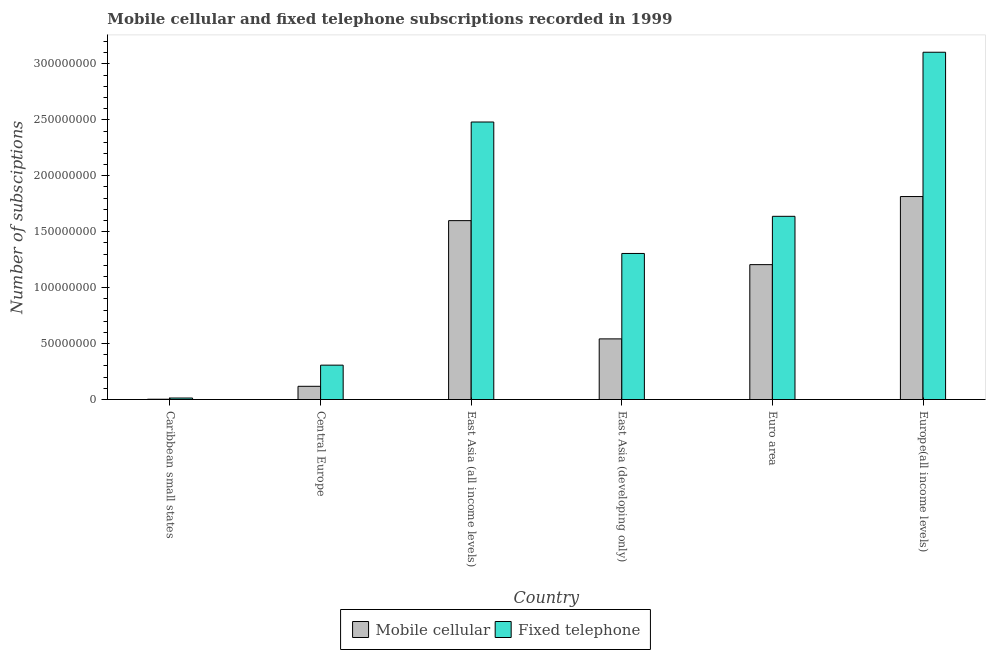How many groups of bars are there?
Your response must be concise. 6. Are the number of bars on each tick of the X-axis equal?
Offer a very short reply. Yes. How many bars are there on the 4th tick from the left?
Offer a terse response. 2. What is the label of the 6th group of bars from the left?
Provide a short and direct response. Europe(all income levels). In how many cases, is the number of bars for a given country not equal to the number of legend labels?
Keep it short and to the point. 0. What is the number of fixed telephone subscriptions in Europe(all income levels)?
Keep it short and to the point. 3.10e+08. Across all countries, what is the maximum number of fixed telephone subscriptions?
Your answer should be compact. 3.10e+08. Across all countries, what is the minimum number of fixed telephone subscriptions?
Give a very brief answer. 1.34e+06. In which country was the number of mobile cellular subscriptions maximum?
Your answer should be compact. Europe(all income levels). In which country was the number of mobile cellular subscriptions minimum?
Your answer should be compact. Caribbean small states. What is the total number of fixed telephone subscriptions in the graph?
Your answer should be very brief. 8.85e+08. What is the difference between the number of mobile cellular subscriptions in East Asia (developing only) and that in Euro area?
Offer a terse response. -6.64e+07. What is the difference between the number of fixed telephone subscriptions in East Asia (developing only) and the number of mobile cellular subscriptions in Central Europe?
Give a very brief answer. 1.19e+08. What is the average number of fixed telephone subscriptions per country?
Make the answer very short. 1.47e+08. What is the difference between the number of fixed telephone subscriptions and number of mobile cellular subscriptions in Central Europe?
Give a very brief answer. 1.89e+07. What is the ratio of the number of fixed telephone subscriptions in East Asia (developing only) to that in Euro area?
Make the answer very short. 0.8. Is the number of mobile cellular subscriptions in Caribbean small states less than that in Europe(all income levels)?
Provide a short and direct response. Yes. Is the difference between the number of mobile cellular subscriptions in Central Europe and Euro area greater than the difference between the number of fixed telephone subscriptions in Central Europe and Euro area?
Offer a terse response. Yes. What is the difference between the highest and the second highest number of mobile cellular subscriptions?
Ensure brevity in your answer.  2.15e+07. What is the difference between the highest and the lowest number of fixed telephone subscriptions?
Offer a very short reply. 3.09e+08. Is the sum of the number of mobile cellular subscriptions in Caribbean small states and East Asia (developing only) greater than the maximum number of fixed telephone subscriptions across all countries?
Ensure brevity in your answer.  No. What does the 2nd bar from the left in East Asia (all income levels) represents?
Give a very brief answer. Fixed telephone. What does the 2nd bar from the right in Europe(all income levels) represents?
Make the answer very short. Mobile cellular. How many bars are there?
Provide a short and direct response. 12. What is the difference between two consecutive major ticks on the Y-axis?
Give a very brief answer. 5.00e+07. Does the graph contain any zero values?
Your answer should be very brief. No. What is the title of the graph?
Offer a terse response. Mobile cellular and fixed telephone subscriptions recorded in 1999. Does "Register a business" appear as one of the legend labels in the graph?
Offer a very short reply. No. What is the label or title of the X-axis?
Your answer should be compact. Country. What is the label or title of the Y-axis?
Keep it short and to the point. Number of subsciptions. What is the Number of subsciptions of Mobile cellular in Caribbean small states?
Ensure brevity in your answer.  2.62e+05. What is the Number of subsciptions in Fixed telephone in Caribbean small states?
Ensure brevity in your answer.  1.34e+06. What is the Number of subsciptions in Mobile cellular in Central Europe?
Your response must be concise. 1.18e+07. What is the Number of subsciptions of Fixed telephone in Central Europe?
Your answer should be very brief. 3.07e+07. What is the Number of subsciptions of Mobile cellular in East Asia (all income levels)?
Your answer should be compact. 1.60e+08. What is the Number of subsciptions in Fixed telephone in East Asia (all income levels)?
Your answer should be very brief. 2.48e+08. What is the Number of subsciptions in Mobile cellular in East Asia (developing only)?
Your response must be concise. 5.42e+07. What is the Number of subsciptions of Fixed telephone in East Asia (developing only)?
Give a very brief answer. 1.31e+08. What is the Number of subsciptions of Mobile cellular in Euro area?
Ensure brevity in your answer.  1.21e+08. What is the Number of subsciptions in Fixed telephone in Euro area?
Offer a very short reply. 1.64e+08. What is the Number of subsciptions in Mobile cellular in Europe(all income levels)?
Make the answer very short. 1.81e+08. What is the Number of subsciptions of Fixed telephone in Europe(all income levels)?
Your answer should be very brief. 3.10e+08. Across all countries, what is the maximum Number of subsciptions in Mobile cellular?
Your answer should be very brief. 1.81e+08. Across all countries, what is the maximum Number of subsciptions in Fixed telephone?
Provide a short and direct response. 3.10e+08. Across all countries, what is the minimum Number of subsciptions of Mobile cellular?
Your response must be concise. 2.62e+05. Across all countries, what is the minimum Number of subsciptions of Fixed telephone?
Ensure brevity in your answer.  1.34e+06. What is the total Number of subsciptions in Mobile cellular in the graph?
Your answer should be compact. 5.28e+08. What is the total Number of subsciptions in Fixed telephone in the graph?
Your answer should be compact. 8.85e+08. What is the difference between the Number of subsciptions of Mobile cellular in Caribbean small states and that in Central Europe?
Your response must be concise. -1.16e+07. What is the difference between the Number of subsciptions of Fixed telephone in Caribbean small states and that in Central Europe?
Offer a terse response. -2.94e+07. What is the difference between the Number of subsciptions in Mobile cellular in Caribbean small states and that in East Asia (all income levels)?
Make the answer very short. -1.60e+08. What is the difference between the Number of subsciptions of Fixed telephone in Caribbean small states and that in East Asia (all income levels)?
Ensure brevity in your answer.  -2.47e+08. What is the difference between the Number of subsciptions in Mobile cellular in Caribbean small states and that in East Asia (developing only)?
Offer a very short reply. -5.39e+07. What is the difference between the Number of subsciptions of Fixed telephone in Caribbean small states and that in East Asia (developing only)?
Your response must be concise. -1.29e+08. What is the difference between the Number of subsciptions in Mobile cellular in Caribbean small states and that in Euro area?
Your answer should be compact. -1.20e+08. What is the difference between the Number of subsciptions of Fixed telephone in Caribbean small states and that in Euro area?
Make the answer very short. -1.62e+08. What is the difference between the Number of subsciptions in Mobile cellular in Caribbean small states and that in Europe(all income levels)?
Offer a terse response. -1.81e+08. What is the difference between the Number of subsciptions in Fixed telephone in Caribbean small states and that in Europe(all income levels)?
Provide a short and direct response. -3.09e+08. What is the difference between the Number of subsciptions in Mobile cellular in Central Europe and that in East Asia (all income levels)?
Your answer should be very brief. -1.48e+08. What is the difference between the Number of subsciptions of Fixed telephone in Central Europe and that in East Asia (all income levels)?
Provide a succinct answer. -2.17e+08. What is the difference between the Number of subsciptions in Mobile cellular in Central Europe and that in East Asia (developing only)?
Make the answer very short. -4.24e+07. What is the difference between the Number of subsciptions in Fixed telephone in Central Europe and that in East Asia (developing only)?
Keep it short and to the point. -9.98e+07. What is the difference between the Number of subsciptions in Mobile cellular in Central Europe and that in Euro area?
Keep it short and to the point. -1.09e+08. What is the difference between the Number of subsciptions of Fixed telephone in Central Europe and that in Euro area?
Give a very brief answer. -1.33e+08. What is the difference between the Number of subsciptions in Mobile cellular in Central Europe and that in Europe(all income levels)?
Offer a terse response. -1.70e+08. What is the difference between the Number of subsciptions of Fixed telephone in Central Europe and that in Europe(all income levels)?
Provide a short and direct response. -2.80e+08. What is the difference between the Number of subsciptions in Mobile cellular in East Asia (all income levels) and that in East Asia (developing only)?
Keep it short and to the point. 1.06e+08. What is the difference between the Number of subsciptions of Fixed telephone in East Asia (all income levels) and that in East Asia (developing only)?
Ensure brevity in your answer.  1.18e+08. What is the difference between the Number of subsciptions in Mobile cellular in East Asia (all income levels) and that in Euro area?
Provide a short and direct response. 3.93e+07. What is the difference between the Number of subsciptions of Fixed telephone in East Asia (all income levels) and that in Euro area?
Provide a short and direct response. 8.43e+07. What is the difference between the Number of subsciptions in Mobile cellular in East Asia (all income levels) and that in Europe(all income levels)?
Your response must be concise. -2.15e+07. What is the difference between the Number of subsciptions in Fixed telephone in East Asia (all income levels) and that in Europe(all income levels)?
Provide a succinct answer. -6.24e+07. What is the difference between the Number of subsciptions in Mobile cellular in East Asia (developing only) and that in Euro area?
Ensure brevity in your answer.  -6.64e+07. What is the difference between the Number of subsciptions of Fixed telephone in East Asia (developing only) and that in Euro area?
Provide a short and direct response. -3.32e+07. What is the difference between the Number of subsciptions of Mobile cellular in East Asia (developing only) and that in Europe(all income levels)?
Give a very brief answer. -1.27e+08. What is the difference between the Number of subsciptions of Fixed telephone in East Asia (developing only) and that in Europe(all income levels)?
Offer a very short reply. -1.80e+08. What is the difference between the Number of subsciptions of Mobile cellular in Euro area and that in Europe(all income levels)?
Keep it short and to the point. -6.09e+07. What is the difference between the Number of subsciptions in Fixed telephone in Euro area and that in Europe(all income levels)?
Provide a short and direct response. -1.47e+08. What is the difference between the Number of subsciptions in Mobile cellular in Caribbean small states and the Number of subsciptions in Fixed telephone in Central Europe?
Give a very brief answer. -3.05e+07. What is the difference between the Number of subsciptions of Mobile cellular in Caribbean small states and the Number of subsciptions of Fixed telephone in East Asia (all income levels)?
Ensure brevity in your answer.  -2.48e+08. What is the difference between the Number of subsciptions in Mobile cellular in Caribbean small states and the Number of subsciptions in Fixed telephone in East Asia (developing only)?
Your response must be concise. -1.30e+08. What is the difference between the Number of subsciptions of Mobile cellular in Caribbean small states and the Number of subsciptions of Fixed telephone in Euro area?
Your response must be concise. -1.63e+08. What is the difference between the Number of subsciptions in Mobile cellular in Caribbean small states and the Number of subsciptions in Fixed telephone in Europe(all income levels)?
Your response must be concise. -3.10e+08. What is the difference between the Number of subsciptions in Mobile cellular in Central Europe and the Number of subsciptions in Fixed telephone in East Asia (all income levels)?
Make the answer very short. -2.36e+08. What is the difference between the Number of subsciptions in Mobile cellular in Central Europe and the Number of subsciptions in Fixed telephone in East Asia (developing only)?
Offer a terse response. -1.19e+08. What is the difference between the Number of subsciptions of Mobile cellular in Central Europe and the Number of subsciptions of Fixed telephone in Euro area?
Ensure brevity in your answer.  -1.52e+08. What is the difference between the Number of subsciptions of Mobile cellular in Central Europe and the Number of subsciptions of Fixed telephone in Europe(all income levels)?
Your response must be concise. -2.99e+08. What is the difference between the Number of subsciptions of Mobile cellular in East Asia (all income levels) and the Number of subsciptions of Fixed telephone in East Asia (developing only)?
Your response must be concise. 2.94e+07. What is the difference between the Number of subsciptions in Mobile cellular in East Asia (all income levels) and the Number of subsciptions in Fixed telephone in Euro area?
Your answer should be compact. -3.85e+06. What is the difference between the Number of subsciptions of Mobile cellular in East Asia (all income levels) and the Number of subsciptions of Fixed telephone in Europe(all income levels)?
Your answer should be very brief. -1.51e+08. What is the difference between the Number of subsciptions of Mobile cellular in East Asia (developing only) and the Number of subsciptions of Fixed telephone in Euro area?
Provide a succinct answer. -1.10e+08. What is the difference between the Number of subsciptions of Mobile cellular in East Asia (developing only) and the Number of subsciptions of Fixed telephone in Europe(all income levels)?
Your answer should be compact. -2.56e+08. What is the difference between the Number of subsciptions in Mobile cellular in Euro area and the Number of subsciptions in Fixed telephone in Europe(all income levels)?
Your answer should be very brief. -1.90e+08. What is the average Number of subsciptions in Mobile cellular per country?
Provide a short and direct response. 8.80e+07. What is the average Number of subsciptions of Fixed telephone per country?
Ensure brevity in your answer.  1.47e+08. What is the difference between the Number of subsciptions of Mobile cellular and Number of subsciptions of Fixed telephone in Caribbean small states?
Make the answer very short. -1.08e+06. What is the difference between the Number of subsciptions in Mobile cellular and Number of subsciptions in Fixed telephone in Central Europe?
Make the answer very short. -1.89e+07. What is the difference between the Number of subsciptions in Mobile cellular and Number of subsciptions in Fixed telephone in East Asia (all income levels)?
Offer a terse response. -8.82e+07. What is the difference between the Number of subsciptions of Mobile cellular and Number of subsciptions of Fixed telephone in East Asia (developing only)?
Keep it short and to the point. -7.63e+07. What is the difference between the Number of subsciptions of Mobile cellular and Number of subsciptions of Fixed telephone in Euro area?
Ensure brevity in your answer.  -4.32e+07. What is the difference between the Number of subsciptions in Mobile cellular and Number of subsciptions in Fixed telephone in Europe(all income levels)?
Your answer should be compact. -1.29e+08. What is the ratio of the Number of subsciptions of Mobile cellular in Caribbean small states to that in Central Europe?
Give a very brief answer. 0.02. What is the ratio of the Number of subsciptions of Fixed telephone in Caribbean small states to that in Central Europe?
Your answer should be very brief. 0.04. What is the ratio of the Number of subsciptions in Mobile cellular in Caribbean small states to that in East Asia (all income levels)?
Offer a very short reply. 0. What is the ratio of the Number of subsciptions in Fixed telephone in Caribbean small states to that in East Asia (all income levels)?
Your answer should be compact. 0.01. What is the ratio of the Number of subsciptions in Mobile cellular in Caribbean small states to that in East Asia (developing only)?
Offer a very short reply. 0. What is the ratio of the Number of subsciptions of Fixed telephone in Caribbean small states to that in East Asia (developing only)?
Offer a very short reply. 0.01. What is the ratio of the Number of subsciptions in Mobile cellular in Caribbean small states to that in Euro area?
Offer a terse response. 0. What is the ratio of the Number of subsciptions of Fixed telephone in Caribbean small states to that in Euro area?
Offer a terse response. 0.01. What is the ratio of the Number of subsciptions of Mobile cellular in Caribbean small states to that in Europe(all income levels)?
Make the answer very short. 0. What is the ratio of the Number of subsciptions in Fixed telephone in Caribbean small states to that in Europe(all income levels)?
Ensure brevity in your answer.  0. What is the ratio of the Number of subsciptions of Mobile cellular in Central Europe to that in East Asia (all income levels)?
Offer a terse response. 0.07. What is the ratio of the Number of subsciptions in Fixed telephone in Central Europe to that in East Asia (all income levels)?
Ensure brevity in your answer.  0.12. What is the ratio of the Number of subsciptions in Mobile cellular in Central Europe to that in East Asia (developing only)?
Provide a short and direct response. 0.22. What is the ratio of the Number of subsciptions of Fixed telephone in Central Europe to that in East Asia (developing only)?
Provide a succinct answer. 0.24. What is the ratio of the Number of subsciptions of Mobile cellular in Central Europe to that in Euro area?
Provide a succinct answer. 0.1. What is the ratio of the Number of subsciptions of Fixed telephone in Central Europe to that in Euro area?
Ensure brevity in your answer.  0.19. What is the ratio of the Number of subsciptions of Mobile cellular in Central Europe to that in Europe(all income levels)?
Make the answer very short. 0.07. What is the ratio of the Number of subsciptions in Fixed telephone in Central Europe to that in Europe(all income levels)?
Provide a short and direct response. 0.1. What is the ratio of the Number of subsciptions of Mobile cellular in East Asia (all income levels) to that in East Asia (developing only)?
Ensure brevity in your answer.  2.95. What is the ratio of the Number of subsciptions of Fixed telephone in East Asia (all income levels) to that in East Asia (developing only)?
Your answer should be very brief. 1.9. What is the ratio of the Number of subsciptions in Mobile cellular in East Asia (all income levels) to that in Euro area?
Keep it short and to the point. 1.33. What is the ratio of the Number of subsciptions in Fixed telephone in East Asia (all income levels) to that in Euro area?
Provide a succinct answer. 1.51. What is the ratio of the Number of subsciptions of Mobile cellular in East Asia (all income levels) to that in Europe(all income levels)?
Your answer should be compact. 0.88. What is the ratio of the Number of subsciptions of Fixed telephone in East Asia (all income levels) to that in Europe(all income levels)?
Your response must be concise. 0.8. What is the ratio of the Number of subsciptions in Mobile cellular in East Asia (developing only) to that in Euro area?
Provide a short and direct response. 0.45. What is the ratio of the Number of subsciptions of Fixed telephone in East Asia (developing only) to that in Euro area?
Make the answer very short. 0.8. What is the ratio of the Number of subsciptions in Mobile cellular in East Asia (developing only) to that in Europe(all income levels)?
Your answer should be very brief. 0.3. What is the ratio of the Number of subsciptions of Fixed telephone in East Asia (developing only) to that in Europe(all income levels)?
Your response must be concise. 0.42. What is the ratio of the Number of subsciptions in Mobile cellular in Euro area to that in Europe(all income levels)?
Offer a terse response. 0.66. What is the ratio of the Number of subsciptions in Fixed telephone in Euro area to that in Europe(all income levels)?
Provide a short and direct response. 0.53. What is the difference between the highest and the second highest Number of subsciptions in Mobile cellular?
Provide a short and direct response. 2.15e+07. What is the difference between the highest and the second highest Number of subsciptions of Fixed telephone?
Your answer should be compact. 6.24e+07. What is the difference between the highest and the lowest Number of subsciptions of Mobile cellular?
Provide a short and direct response. 1.81e+08. What is the difference between the highest and the lowest Number of subsciptions in Fixed telephone?
Your answer should be compact. 3.09e+08. 